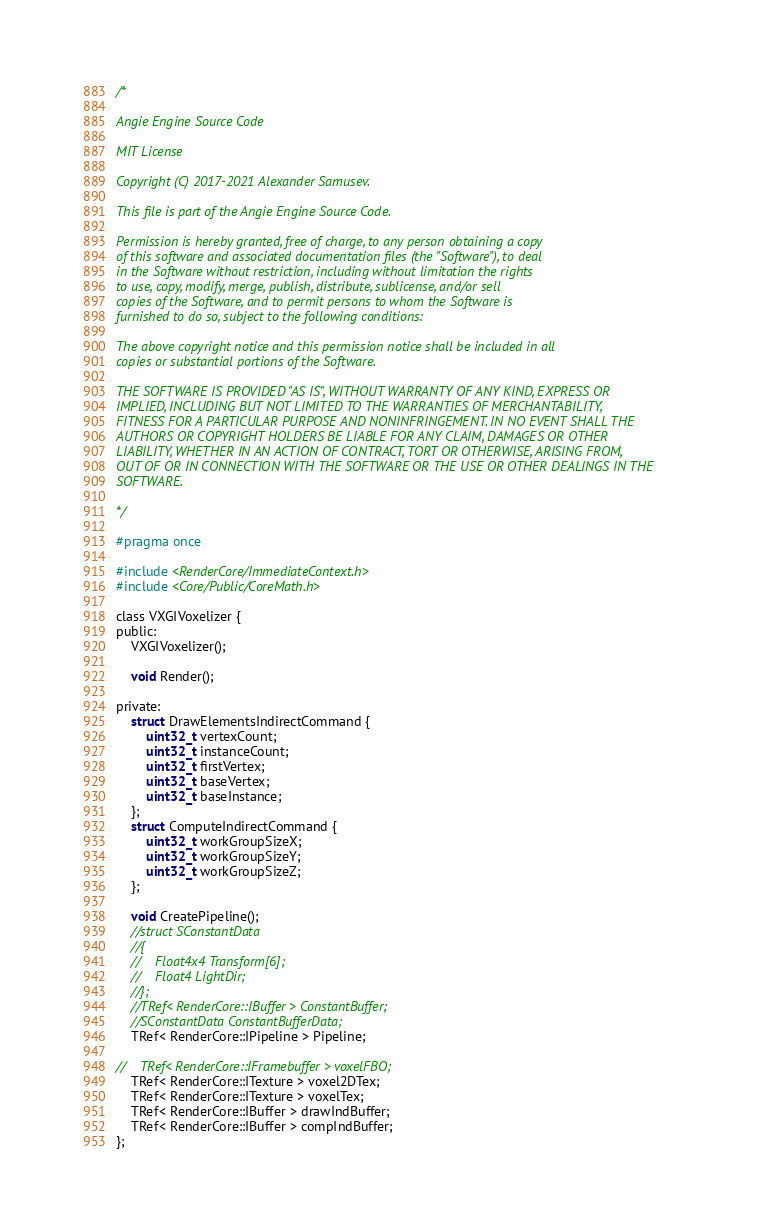Convert code to text. <code><loc_0><loc_0><loc_500><loc_500><_C_>/*

Angie Engine Source Code

MIT License

Copyright (C) 2017-2021 Alexander Samusev.

This file is part of the Angie Engine Source Code.

Permission is hereby granted, free of charge, to any person obtaining a copy
of this software and associated documentation files (the "Software"), to deal
in the Software without restriction, including without limitation the rights
to use, copy, modify, merge, publish, distribute, sublicense, and/or sell
copies of the Software, and to permit persons to whom the Software is
furnished to do so, subject to the following conditions:

The above copyright notice and this permission notice shall be included in all
copies or substantial portions of the Software.

THE SOFTWARE IS PROVIDED "AS IS", WITHOUT WARRANTY OF ANY KIND, EXPRESS OR
IMPLIED, INCLUDING BUT NOT LIMITED TO THE WARRANTIES OF MERCHANTABILITY,
FITNESS FOR A PARTICULAR PURPOSE AND NONINFRINGEMENT. IN NO EVENT SHALL THE
AUTHORS OR COPYRIGHT HOLDERS BE LIABLE FOR ANY CLAIM, DAMAGES OR OTHER
LIABILITY, WHETHER IN AN ACTION OF CONTRACT, TORT OR OTHERWISE, ARISING FROM,
OUT OF OR IN CONNECTION WITH THE SOFTWARE OR THE USE OR OTHER DEALINGS IN THE
SOFTWARE.

*/

#pragma once

#include <RenderCore/ImmediateContext.h>
#include <Core/Public/CoreMath.h>

class VXGIVoxelizer {
public:
    VXGIVoxelizer();

    void Render();

private:
    struct DrawElementsIndirectCommand {
        uint32_t vertexCount;
        uint32_t instanceCount;
        uint32_t firstVertex;
        uint32_t baseVertex;
        uint32_t baseInstance;
    };
    struct ComputeIndirectCommand {
        uint32_t workGroupSizeX;
        uint32_t workGroupSizeY;
        uint32_t workGroupSizeZ;
    };

    void CreatePipeline();
    //struct SConstantData
    //{
    //    Float4x4 Transform[6];
    //    Float4 LightDir;
    //};
    //TRef< RenderCore::IBuffer > ConstantBuffer;
    //SConstantData ConstantBufferData;
    TRef< RenderCore::IPipeline > Pipeline;

//    TRef< RenderCore::IFramebuffer > voxelFBO;
    TRef< RenderCore::ITexture > voxel2DTex;
    TRef< RenderCore::ITexture > voxelTex;
    TRef< RenderCore::IBuffer > drawIndBuffer;
    TRef< RenderCore::IBuffer > compIndBuffer;
};
</code> 